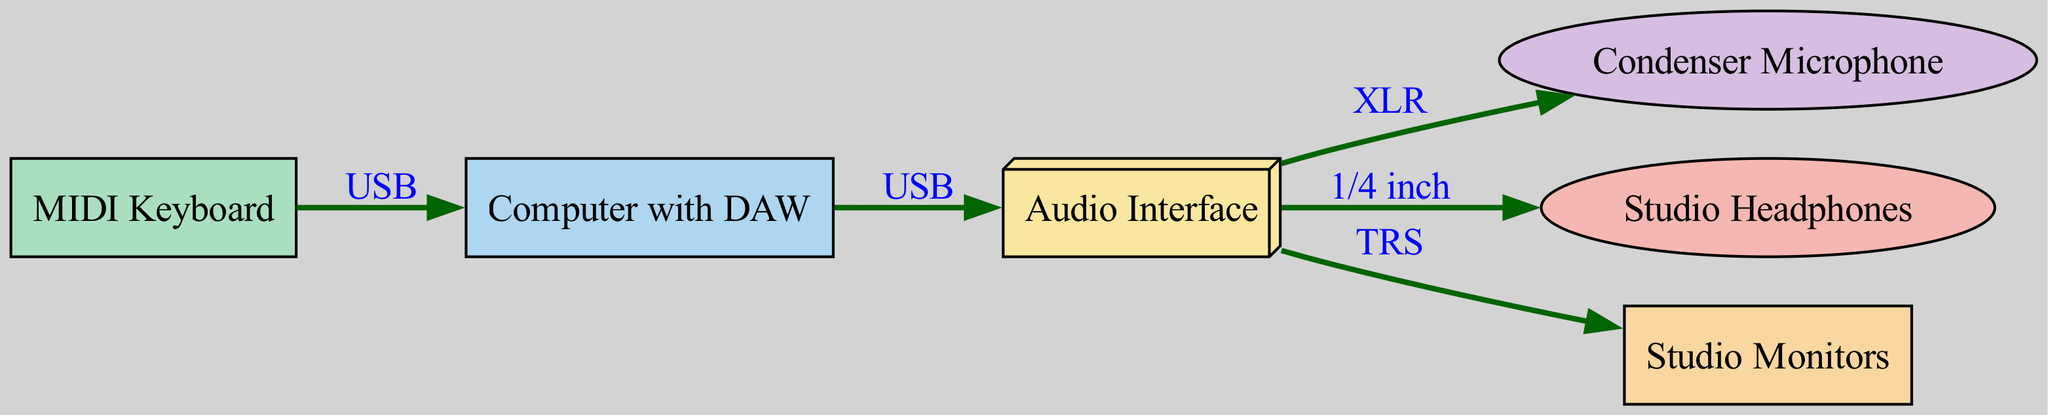What is the primary function of the Audio Interface? The Audio Interface serves as the central hub for connecting various audio equipment to the computer. It allows for the input and output of audio signals, enabling recording and monitoring.
Answer: Central hub for audio connections How many nodes are present in the diagram? By counting the listed nodes, we find there are six distinct components: Computer with DAW, Audio Interface, Condenser Microphone, Studio Headphones, MIDI Keyboard, and Studio Monitors.
Answer: Six What type of connection is used between the Computer and the Audio Interface? The diagram indicates that the connection from Computer to Audio Interface is via USB, which is a standard interface for data transfer and power supply.
Answer: USB What equipment is directly connected to the Audio Interface with an XLR cable? According to the diagram, the Condenser Microphone connects directly to the Audio Interface using an XLR cable, a common cable type for audio.
Answer: Condenser Microphone Which equipment receives audio output through TRS from the Audio Interface? The diagram specifies that the Studio Monitors are connected to the Audio Interface using a TRS connection, which is suitable for transmitting audio signals.
Answer: Studio Monitors Which two pieces of equipment connect to the Audio Interface but receive different types of output connections? The Studio Headphones use a 1/4 inch connection and the Studio Monitors use a TRS connection from the Audio Interface. This highlights the variety of output options available.
Answer: Studio Headphones and Studio Monitors What kind of input cable is used for connecting the MIDI Keyboard to the Computer? The MIDI Keyboard connects to the Computer using a USB cable, which is typically used for digital music communication between devices.
Answer: USB What color is associated with the Studio Headphones in the diagram? The diagram visually represents the Studio Headphones using a light red color (F5B7B1), indicating the style and purpose through color choice.
Answer: Light red 